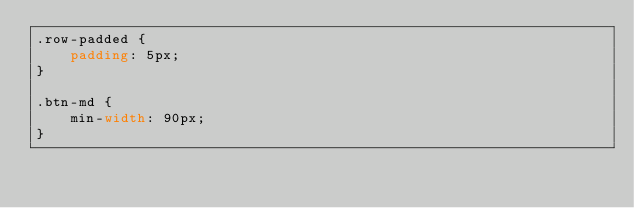Convert code to text. <code><loc_0><loc_0><loc_500><loc_500><_CSS_>.row-padded {
    padding: 5px;
}

.btn-md {
    min-width: 90px;
}</code> 